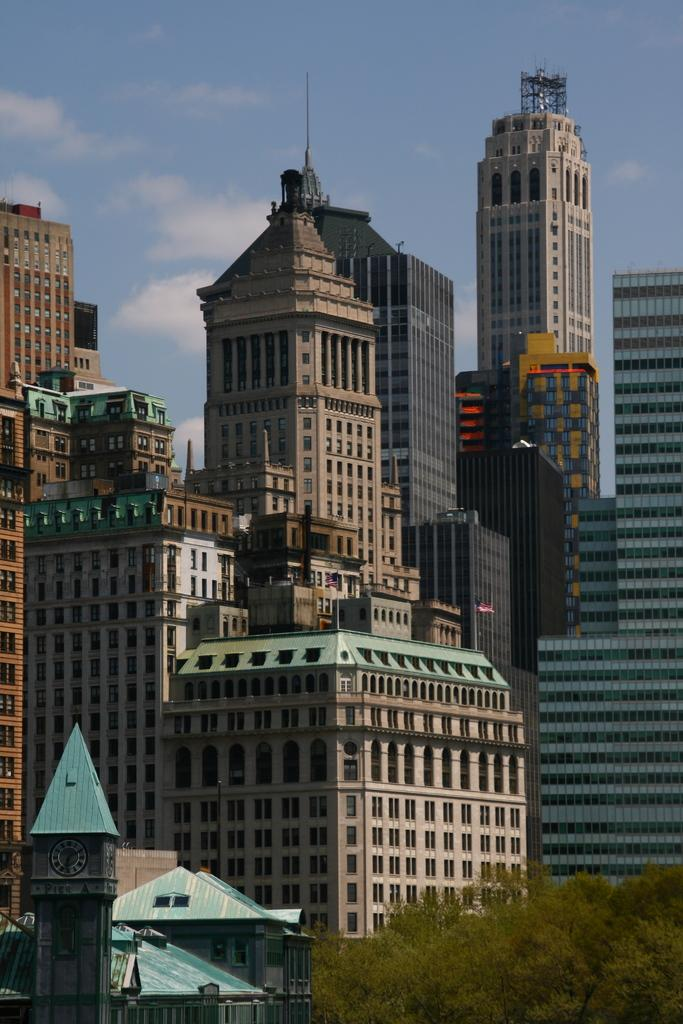What type of structures can be seen in the image? There are buildings in the image. What other natural elements are present in the image? There are trees in the image. Can you describe a specific feature of one of the buildings? There is a clock tower with a clock in the image. What can be seen in the background of the image? The sky is visible in the background of the image. What is the weather like in the image? The presence of clouds in the sky suggests that it might be partly cloudy. What type of pest can be seen crawling on the clock tower in the image? There are no pests visible on the clock tower in the image. Can you tell me how many seeds are scattered around the base of the trees in the image? There are no seeds visible at the base of the trees in the image. 